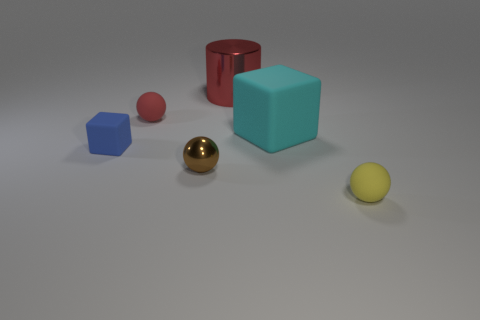How many other things are made of the same material as the brown object?
Your answer should be very brief. 1. There is a red matte object that is the same shape as the brown shiny thing; what size is it?
Offer a terse response. Small. Do the cyan block and the blue thing have the same size?
Offer a very short reply. No. What shape is the tiny object on the right side of the red thing that is behind the tiny rubber object behind the cyan rubber thing?
Provide a short and direct response. Sphere. There is a big matte thing that is the same shape as the tiny blue thing; what is its color?
Offer a terse response. Cyan. There is a rubber object that is both left of the large red cylinder and right of the tiny blue thing; how big is it?
Provide a succinct answer. Small. There is a big red thing behind the small thing left of the small red ball; what number of small matte things are to the left of it?
Your answer should be compact. 2. How many small objects are either cylinders or red matte spheres?
Provide a short and direct response. 1. Is the material of the large block behind the small rubber cube the same as the red cylinder?
Offer a very short reply. No. What is the material of the red object behind the red object in front of the metal thing that is right of the tiny brown shiny sphere?
Your response must be concise. Metal. 